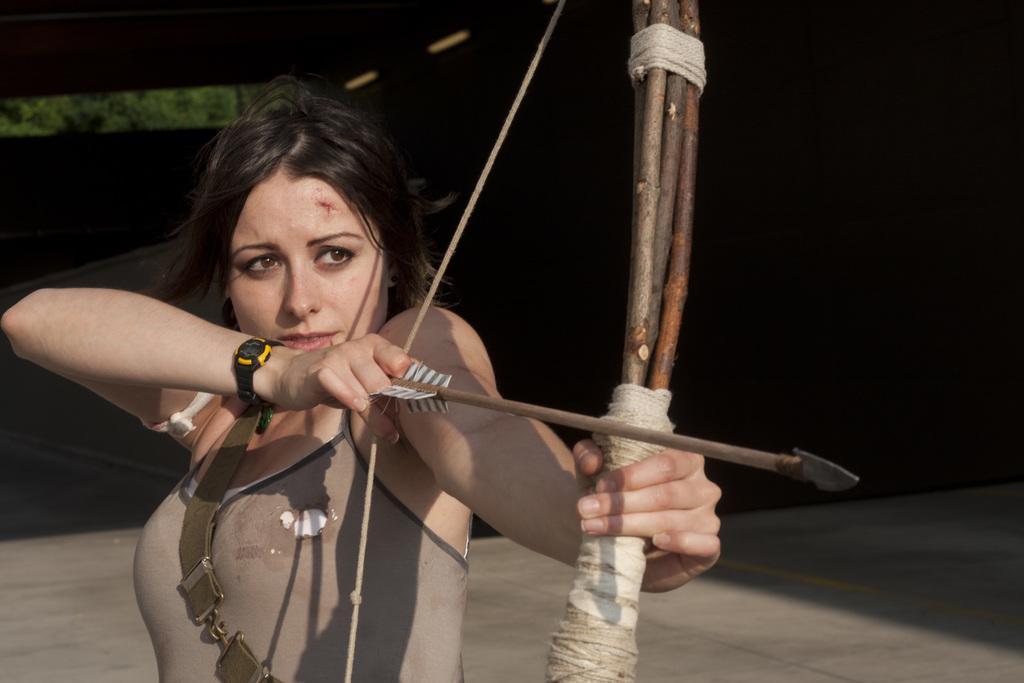Can you describe this image briefly? In this image I can see a woman wearing watch, dress is standing and holding a bow and a arrow in her hands. In the background I can see the ground and the black background. 